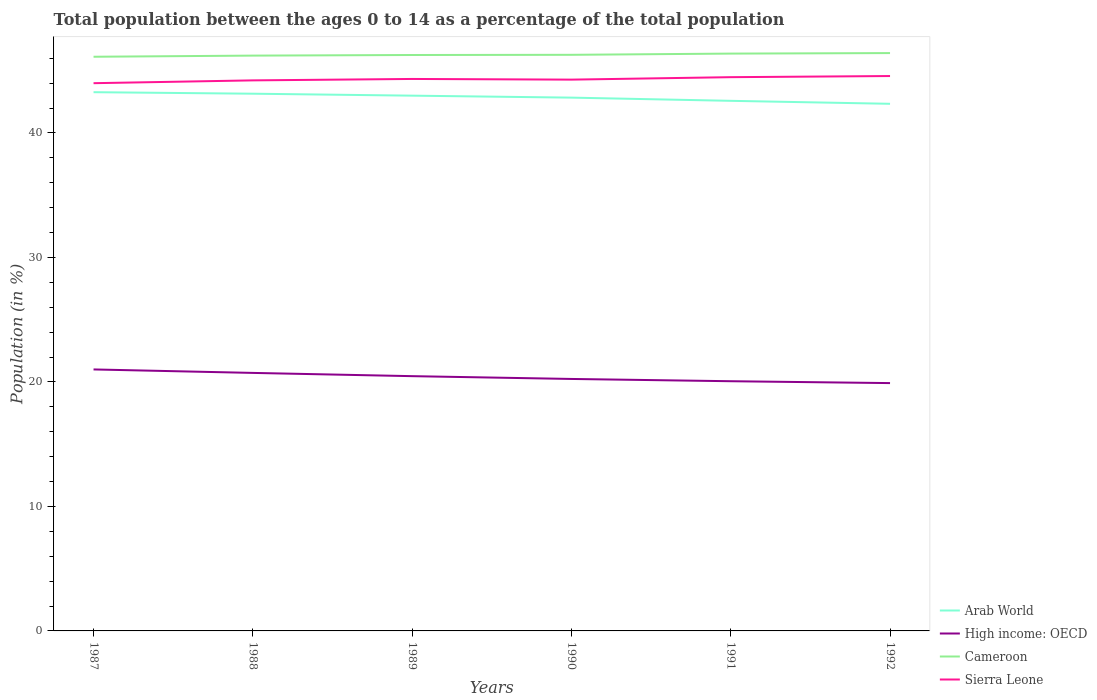Does the line corresponding to Arab World intersect with the line corresponding to Cameroon?
Offer a terse response. No. Across all years, what is the maximum percentage of the population ages 0 to 14 in Sierra Leone?
Offer a very short reply. 44. What is the total percentage of the population ages 0 to 14 in Cameroon in the graph?
Give a very brief answer. -0.05. What is the difference between the highest and the second highest percentage of the population ages 0 to 14 in Arab World?
Ensure brevity in your answer.  0.93. What is the difference between the highest and the lowest percentage of the population ages 0 to 14 in Cameroon?
Offer a terse response. 3. Is the percentage of the population ages 0 to 14 in Cameroon strictly greater than the percentage of the population ages 0 to 14 in High income: OECD over the years?
Offer a terse response. No. How many lines are there?
Give a very brief answer. 4. How many years are there in the graph?
Give a very brief answer. 6. What is the difference between two consecutive major ticks on the Y-axis?
Make the answer very short. 10. Where does the legend appear in the graph?
Your response must be concise. Bottom right. How are the legend labels stacked?
Your response must be concise. Vertical. What is the title of the graph?
Provide a short and direct response. Total population between the ages 0 to 14 as a percentage of the total population. What is the label or title of the Y-axis?
Give a very brief answer. Population (in %). What is the Population (in %) in Arab World in 1987?
Your response must be concise. 43.28. What is the Population (in %) of High income: OECD in 1987?
Provide a succinct answer. 21.01. What is the Population (in %) of Cameroon in 1987?
Offer a very short reply. 46.12. What is the Population (in %) of Sierra Leone in 1987?
Provide a succinct answer. 44. What is the Population (in %) of Arab World in 1988?
Your answer should be compact. 43.16. What is the Population (in %) of High income: OECD in 1988?
Keep it short and to the point. 20.73. What is the Population (in %) of Cameroon in 1988?
Provide a short and direct response. 46.22. What is the Population (in %) in Sierra Leone in 1988?
Your response must be concise. 44.23. What is the Population (in %) in Arab World in 1989?
Make the answer very short. 43. What is the Population (in %) in High income: OECD in 1989?
Give a very brief answer. 20.47. What is the Population (in %) in Cameroon in 1989?
Make the answer very short. 46.26. What is the Population (in %) in Sierra Leone in 1989?
Provide a succinct answer. 44.34. What is the Population (in %) of Arab World in 1990?
Make the answer very short. 42.84. What is the Population (in %) in High income: OECD in 1990?
Offer a very short reply. 20.24. What is the Population (in %) of Cameroon in 1990?
Offer a very short reply. 46.28. What is the Population (in %) of Sierra Leone in 1990?
Your answer should be very brief. 44.29. What is the Population (in %) of Arab World in 1991?
Give a very brief answer. 42.58. What is the Population (in %) in High income: OECD in 1991?
Make the answer very short. 20.06. What is the Population (in %) of Cameroon in 1991?
Provide a short and direct response. 46.38. What is the Population (in %) in Sierra Leone in 1991?
Offer a very short reply. 44.48. What is the Population (in %) of Arab World in 1992?
Keep it short and to the point. 42.35. What is the Population (in %) of High income: OECD in 1992?
Your answer should be very brief. 19.91. What is the Population (in %) of Cameroon in 1992?
Ensure brevity in your answer.  46.42. What is the Population (in %) in Sierra Leone in 1992?
Ensure brevity in your answer.  44.58. Across all years, what is the maximum Population (in %) in Arab World?
Keep it short and to the point. 43.28. Across all years, what is the maximum Population (in %) of High income: OECD?
Ensure brevity in your answer.  21.01. Across all years, what is the maximum Population (in %) in Cameroon?
Make the answer very short. 46.42. Across all years, what is the maximum Population (in %) of Sierra Leone?
Provide a short and direct response. 44.58. Across all years, what is the minimum Population (in %) in Arab World?
Your response must be concise. 42.35. Across all years, what is the minimum Population (in %) in High income: OECD?
Provide a succinct answer. 19.91. Across all years, what is the minimum Population (in %) in Cameroon?
Provide a succinct answer. 46.12. Across all years, what is the minimum Population (in %) in Sierra Leone?
Your answer should be compact. 44. What is the total Population (in %) of Arab World in the graph?
Keep it short and to the point. 257.2. What is the total Population (in %) of High income: OECD in the graph?
Your response must be concise. 122.41. What is the total Population (in %) of Cameroon in the graph?
Provide a short and direct response. 277.68. What is the total Population (in %) in Sierra Leone in the graph?
Provide a succinct answer. 265.91. What is the difference between the Population (in %) in Arab World in 1987 and that in 1988?
Your answer should be very brief. 0.12. What is the difference between the Population (in %) of High income: OECD in 1987 and that in 1988?
Provide a succinct answer. 0.28. What is the difference between the Population (in %) of Cameroon in 1987 and that in 1988?
Your response must be concise. -0.09. What is the difference between the Population (in %) of Sierra Leone in 1987 and that in 1988?
Give a very brief answer. -0.23. What is the difference between the Population (in %) of Arab World in 1987 and that in 1989?
Offer a terse response. 0.28. What is the difference between the Population (in %) in High income: OECD in 1987 and that in 1989?
Your response must be concise. 0.54. What is the difference between the Population (in %) in Cameroon in 1987 and that in 1989?
Offer a terse response. -0.14. What is the difference between the Population (in %) of Sierra Leone in 1987 and that in 1989?
Give a very brief answer. -0.34. What is the difference between the Population (in %) of Arab World in 1987 and that in 1990?
Give a very brief answer. 0.44. What is the difference between the Population (in %) of High income: OECD in 1987 and that in 1990?
Provide a succinct answer. 0.76. What is the difference between the Population (in %) of Cameroon in 1987 and that in 1990?
Your answer should be very brief. -0.16. What is the difference between the Population (in %) in Sierra Leone in 1987 and that in 1990?
Ensure brevity in your answer.  -0.29. What is the difference between the Population (in %) of Arab World in 1987 and that in 1991?
Provide a succinct answer. 0.69. What is the difference between the Population (in %) in High income: OECD in 1987 and that in 1991?
Make the answer very short. 0.95. What is the difference between the Population (in %) in Cameroon in 1987 and that in 1991?
Your answer should be compact. -0.25. What is the difference between the Population (in %) in Sierra Leone in 1987 and that in 1991?
Your answer should be very brief. -0.48. What is the difference between the Population (in %) of Arab World in 1987 and that in 1992?
Give a very brief answer. 0.93. What is the difference between the Population (in %) in High income: OECD in 1987 and that in 1992?
Offer a terse response. 1.1. What is the difference between the Population (in %) in Cameroon in 1987 and that in 1992?
Offer a terse response. -0.3. What is the difference between the Population (in %) in Sierra Leone in 1987 and that in 1992?
Your answer should be compact. -0.58. What is the difference between the Population (in %) in Arab World in 1988 and that in 1989?
Your answer should be compact. 0.16. What is the difference between the Population (in %) in High income: OECD in 1988 and that in 1989?
Make the answer very short. 0.26. What is the difference between the Population (in %) of Cameroon in 1988 and that in 1989?
Keep it short and to the point. -0.05. What is the difference between the Population (in %) in Sierra Leone in 1988 and that in 1989?
Your answer should be compact. -0.11. What is the difference between the Population (in %) of Arab World in 1988 and that in 1990?
Provide a short and direct response. 0.32. What is the difference between the Population (in %) in High income: OECD in 1988 and that in 1990?
Give a very brief answer. 0.48. What is the difference between the Population (in %) of Cameroon in 1988 and that in 1990?
Keep it short and to the point. -0.06. What is the difference between the Population (in %) in Sierra Leone in 1988 and that in 1990?
Offer a terse response. -0.06. What is the difference between the Population (in %) in Arab World in 1988 and that in 1991?
Keep it short and to the point. 0.57. What is the difference between the Population (in %) of High income: OECD in 1988 and that in 1991?
Provide a short and direct response. 0.67. What is the difference between the Population (in %) in Cameroon in 1988 and that in 1991?
Keep it short and to the point. -0.16. What is the difference between the Population (in %) in Sierra Leone in 1988 and that in 1991?
Ensure brevity in your answer.  -0.26. What is the difference between the Population (in %) of Arab World in 1988 and that in 1992?
Offer a very short reply. 0.81. What is the difference between the Population (in %) of High income: OECD in 1988 and that in 1992?
Keep it short and to the point. 0.82. What is the difference between the Population (in %) in Cameroon in 1988 and that in 1992?
Offer a terse response. -0.2. What is the difference between the Population (in %) of Sierra Leone in 1988 and that in 1992?
Offer a very short reply. -0.35. What is the difference between the Population (in %) of Arab World in 1989 and that in 1990?
Keep it short and to the point. 0.16. What is the difference between the Population (in %) in High income: OECD in 1989 and that in 1990?
Ensure brevity in your answer.  0.22. What is the difference between the Population (in %) in Cameroon in 1989 and that in 1990?
Keep it short and to the point. -0.02. What is the difference between the Population (in %) of Sierra Leone in 1989 and that in 1990?
Your answer should be compact. 0.05. What is the difference between the Population (in %) in Arab World in 1989 and that in 1991?
Your answer should be very brief. 0.42. What is the difference between the Population (in %) of High income: OECD in 1989 and that in 1991?
Ensure brevity in your answer.  0.41. What is the difference between the Population (in %) of Cameroon in 1989 and that in 1991?
Your response must be concise. -0.11. What is the difference between the Population (in %) in Sierra Leone in 1989 and that in 1991?
Make the answer very short. -0.14. What is the difference between the Population (in %) in Arab World in 1989 and that in 1992?
Keep it short and to the point. 0.65. What is the difference between the Population (in %) in High income: OECD in 1989 and that in 1992?
Provide a short and direct response. 0.56. What is the difference between the Population (in %) of Cameroon in 1989 and that in 1992?
Your answer should be very brief. -0.15. What is the difference between the Population (in %) of Sierra Leone in 1989 and that in 1992?
Give a very brief answer. -0.24. What is the difference between the Population (in %) in Arab World in 1990 and that in 1991?
Your response must be concise. 0.26. What is the difference between the Population (in %) of High income: OECD in 1990 and that in 1991?
Provide a short and direct response. 0.18. What is the difference between the Population (in %) of Cameroon in 1990 and that in 1991?
Give a very brief answer. -0.1. What is the difference between the Population (in %) in Sierra Leone in 1990 and that in 1991?
Provide a short and direct response. -0.2. What is the difference between the Population (in %) of Arab World in 1990 and that in 1992?
Provide a short and direct response. 0.5. What is the difference between the Population (in %) of High income: OECD in 1990 and that in 1992?
Keep it short and to the point. 0.33. What is the difference between the Population (in %) of Cameroon in 1990 and that in 1992?
Provide a succinct answer. -0.14. What is the difference between the Population (in %) in Sierra Leone in 1990 and that in 1992?
Provide a succinct answer. -0.29. What is the difference between the Population (in %) of Arab World in 1991 and that in 1992?
Offer a very short reply. 0.24. What is the difference between the Population (in %) in High income: OECD in 1991 and that in 1992?
Your answer should be very brief. 0.15. What is the difference between the Population (in %) of Cameroon in 1991 and that in 1992?
Provide a succinct answer. -0.04. What is the difference between the Population (in %) in Sierra Leone in 1991 and that in 1992?
Keep it short and to the point. -0.09. What is the difference between the Population (in %) of Arab World in 1987 and the Population (in %) of High income: OECD in 1988?
Your answer should be very brief. 22.55. What is the difference between the Population (in %) of Arab World in 1987 and the Population (in %) of Cameroon in 1988?
Your response must be concise. -2.94. What is the difference between the Population (in %) in Arab World in 1987 and the Population (in %) in Sierra Leone in 1988?
Give a very brief answer. -0.95. What is the difference between the Population (in %) of High income: OECD in 1987 and the Population (in %) of Cameroon in 1988?
Ensure brevity in your answer.  -25.21. What is the difference between the Population (in %) in High income: OECD in 1987 and the Population (in %) in Sierra Leone in 1988?
Your answer should be very brief. -23.22. What is the difference between the Population (in %) of Cameroon in 1987 and the Population (in %) of Sierra Leone in 1988?
Your answer should be compact. 1.9. What is the difference between the Population (in %) of Arab World in 1987 and the Population (in %) of High income: OECD in 1989?
Provide a succinct answer. 22.81. What is the difference between the Population (in %) of Arab World in 1987 and the Population (in %) of Cameroon in 1989?
Offer a very short reply. -2.99. What is the difference between the Population (in %) in Arab World in 1987 and the Population (in %) in Sierra Leone in 1989?
Give a very brief answer. -1.06. What is the difference between the Population (in %) of High income: OECD in 1987 and the Population (in %) of Cameroon in 1989?
Your answer should be very brief. -25.26. What is the difference between the Population (in %) of High income: OECD in 1987 and the Population (in %) of Sierra Leone in 1989?
Your answer should be compact. -23.34. What is the difference between the Population (in %) in Cameroon in 1987 and the Population (in %) in Sierra Leone in 1989?
Your response must be concise. 1.78. What is the difference between the Population (in %) of Arab World in 1987 and the Population (in %) of High income: OECD in 1990?
Offer a very short reply. 23.04. What is the difference between the Population (in %) of Arab World in 1987 and the Population (in %) of Cameroon in 1990?
Your response must be concise. -3. What is the difference between the Population (in %) of Arab World in 1987 and the Population (in %) of Sierra Leone in 1990?
Offer a very short reply. -1.01. What is the difference between the Population (in %) in High income: OECD in 1987 and the Population (in %) in Cameroon in 1990?
Make the answer very short. -25.27. What is the difference between the Population (in %) of High income: OECD in 1987 and the Population (in %) of Sierra Leone in 1990?
Offer a terse response. -23.28. What is the difference between the Population (in %) in Cameroon in 1987 and the Population (in %) in Sierra Leone in 1990?
Give a very brief answer. 1.84. What is the difference between the Population (in %) in Arab World in 1987 and the Population (in %) in High income: OECD in 1991?
Keep it short and to the point. 23.22. What is the difference between the Population (in %) in Arab World in 1987 and the Population (in %) in Cameroon in 1991?
Provide a succinct answer. -3.1. What is the difference between the Population (in %) in Arab World in 1987 and the Population (in %) in Sierra Leone in 1991?
Your answer should be compact. -1.21. What is the difference between the Population (in %) in High income: OECD in 1987 and the Population (in %) in Cameroon in 1991?
Your answer should be very brief. -25.37. What is the difference between the Population (in %) in High income: OECD in 1987 and the Population (in %) in Sierra Leone in 1991?
Your answer should be compact. -23.48. What is the difference between the Population (in %) in Cameroon in 1987 and the Population (in %) in Sierra Leone in 1991?
Provide a succinct answer. 1.64. What is the difference between the Population (in %) in Arab World in 1987 and the Population (in %) in High income: OECD in 1992?
Make the answer very short. 23.37. What is the difference between the Population (in %) in Arab World in 1987 and the Population (in %) in Cameroon in 1992?
Give a very brief answer. -3.14. What is the difference between the Population (in %) of Arab World in 1987 and the Population (in %) of Sierra Leone in 1992?
Offer a terse response. -1.3. What is the difference between the Population (in %) of High income: OECD in 1987 and the Population (in %) of Cameroon in 1992?
Provide a short and direct response. -25.41. What is the difference between the Population (in %) in High income: OECD in 1987 and the Population (in %) in Sierra Leone in 1992?
Your answer should be compact. -23.57. What is the difference between the Population (in %) in Cameroon in 1987 and the Population (in %) in Sierra Leone in 1992?
Your answer should be compact. 1.55. What is the difference between the Population (in %) in Arab World in 1988 and the Population (in %) in High income: OECD in 1989?
Make the answer very short. 22.69. What is the difference between the Population (in %) of Arab World in 1988 and the Population (in %) of Cameroon in 1989?
Keep it short and to the point. -3.11. What is the difference between the Population (in %) in Arab World in 1988 and the Population (in %) in Sierra Leone in 1989?
Keep it short and to the point. -1.18. What is the difference between the Population (in %) in High income: OECD in 1988 and the Population (in %) in Cameroon in 1989?
Offer a terse response. -25.54. What is the difference between the Population (in %) in High income: OECD in 1988 and the Population (in %) in Sierra Leone in 1989?
Make the answer very short. -23.61. What is the difference between the Population (in %) of Cameroon in 1988 and the Population (in %) of Sierra Leone in 1989?
Ensure brevity in your answer.  1.88. What is the difference between the Population (in %) of Arab World in 1988 and the Population (in %) of High income: OECD in 1990?
Keep it short and to the point. 22.91. What is the difference between the Population (in %) in Arab World in 1988 and the Population (in %) in Cameroon in 1990?
Ensure brevity in your answer.  -3.12. What is the difference between the Population (in %) in Arab World in 1988 and the Population (in %) in Sierra Leone in 1990?
Offer a terse response. -1.13. What is the difference between the Population (in %) of High income: OECD in 1988 and the Population (in %) of Cameroon in 1990?
Provide a succinct answer. -25.55. What is the difference between the Population (in %) of High income: OECD in 1988 and the Population (in %) of Sierra Leone in 1990?
Provide a short and direct response. -23.56. What is the difference between the Population (in %) of Cameroon in 1988 and the Population (in %) of Sierra Leone in 1990?
Your answer should be compact. 1.93. What is the difference between the Population (in %) of Arab World in 1988 and the Population (in %) of High income: OECD in 1991?
Provide a succinct answer. 23.1. What is the difference between the Population (in %) in Arab World in 1988 and the Population (in %) in Cameroon in 1991?
Ensure brevity in your answer.  -3.22. What is the difference between the Population (in %) of Arab World in 1988 and the Population (in %) of Sierra Leone in 1991?
Offer a very short reply. -1.33. What is the difference between the Population (in %) of High income: OECD in 1988 and the Population (in %) of Cameroon in 1991?
Your response must be concise. -25.65. What is the difference between the Population (in %) of High income: OECD in 1988 and the Population (in %) of Sierra Leone in 1991?
Give a very brief answer. -23.76. What is the difference between the Population (in %) in Cameroon in 1988 and the Population (in %) in Sierra Leone in 1991?
Offer a terse response. 1.73. What is the difference between the Population (in %) in Arab World in 1988 and the Population (in %) in High income: OECD in 1992?
Offer a very short reply. 23.25. What is the difference between the Population (in %) of Arab World in 1988 and the Population (in %) of Cameroon in 1992?
Provide a succinct answer. -3.26. What is the difference between the Population (in %) of Arab World in 1988 and the Population (in %) of Sierra Leone in 1992?
Provide a short and direct response. -1.42. What is the difference between the Population (in %) in High income: OECD in 1988 and the Population (in %) in Cameroon in 1992?
Provide a short and direct response. -25.69. What is the difference between the Population (in %) in High income: OECD in 1988 and the Population (in %) in Sierra Leone in 1992?
Offer a terse response. -23.85. What is the difference between the Population (in %) in Cameroon in 1988 and the Population (in %) in Sierra Leone in 1992?
Give a very brief answer. 1.64. What is the difference between the Population (in %) of Arab World in 1989 and the Population (in %) of High income: OECD in 1990?
Your response must be concise. 22.76. What is the difference between the Population (in %) of Arab World in 1989 and the Population (in %) of Cameroon in 1990?
Give a very brief answer. -3.28. What is the difference between the Population (in %) in Arab World in 1989 and the Population (in %) in Sierra Leone in 1990?
Offer a terse response. -1.29. What is the difference between the Population (in %) of High income: OECD in 1989 and the Population (in %) of Cameroon in 1990?
Your answer should be very brief. -25.81. What is the difference between the Population (in %) in High income: OECD in 1989 and the Population (in %) in Sierra Leone in 1990?
Give a very brief answer. -23.82. What is the difference between the Population (in %) of Cameroon in 1989 and the Population (in %) of Sierra Leone in 1990?
Your response must be concise. 1.98. What is the difference between the Population (in %) of Arab World in 1989 and the Population (in %) of High income: OECD in 1991?
Give a very brief answer. 22.94. What is the difference between the Population (in %) in Arab World in 1989 and the Population (in %) in Cameroon in 1991?
Your answer should be compact. -3.38. What is the difference between the Population (in %) in Arab World in 1989 and the Population (in %) in Sierra Leone in 1991?
Ensure brevity in your answer.  -1.48. What is the difference between the Population (in %) in High income: OECD in 1989 and the Population (in %) in Cameroon in 1991?
Make the answer very short. -25.91. What is the difference between the Population (in %) of High income: OECD in 1989 and the Population (in %) of Sierra Leone in 1991?
Offer a very short reply. -24.02. What is the difference between the Population (in %) of Cameroon in 1989 and the Population (in %) of Sierra Leone in 1991?
Offer a very short reply. 1.78. What is the difference between the Population (in %) in Arab World in 1989 and the Population (in %) in High income: OECD in 1992?
Provide a succinct answer. 23.09. What is the difference between the Population (in %) of Arab World in 1989 and the Population (in %) of Cameroon in 1992?
Offer a very short reply. -3.42. What is the difference between the Population (in %) of Arab World in 1989 and the Population (in %) of Sierra Leone in 1992?
Provide a succinct answer. -1.58. What is the difference between the Population (in %) in High income: OECD in 1989 and the Population (in %) in Cameroon in 1992?
Provide a succinct answer. -25.95. What is the difference between the Population (in %) of High income: OECD in 1989 and the Population (in %) of Sierra Leone in 1992?
Provide a succinct answer. -24.11. What is the difference between the Population (in %) in Cameroon in 1989 and the Population (in %) in Sierra Leone in 1992?
Provide a short and direct response. 1.69. What is the difference between the Population (in %) of Arab World in 1990 and the Population (in %) of High income: OECD in 1991?
Your response must be concise. 22.78. What is the difference between the Population (in %) in Arab World in 1990 and the Population (in %) in Cameroon in 1991?
Your answer should be compact. -3.54. What is the difference between the Population (in %) of Arab World in 1990 and the Population (in %) of Sierra Leone in 1991?
Keep it short and to the point. -1.64. What is the difference between the Population (in %) in High income: OECD in 1990 and the Population (in %) in Cameroon in 1991?
Make the answer very short. -26.14. What is the difference between the Population (in %) in High income: OECD in 1990 and the Population (in %) in Sierra Leone in 1991?
Ensure brevity in your answer.  -24.24. What is the difference between the Population (in %) of Cameroon in 1990 and the Population (in %) of Sierra Leone in 1991?
Your response must be concise. 1.8. What is the difference between the Population (in %) of Arab World in 1990 and the Population (in %) of High income: OECD in 1992?
Your answer should be compact. 22.93. What is the difference between the Population (in %) of Arab World in 1990 and the Population (in %) of Cameroon in 1992?
Offer a very short reply. -3.58. What is the difference between the Population (in %) in Arab World in 1990 and the Population (in %) in Sierra Leone in 1992?
Provide a succinct answer. -1.74. What is the difference between the Population (in %) in High income: OECD in 1990 and the Population (in %) in Cameroon in 1992?
Your answer should be compact. -26.18. What is the difference between the Population (in %) in High income: OECD in 1990 and the Population (in %) in Sierra Leone in 1992?
Your response must be concise. -24.33. What is the difference between the Population (in %) of Cameroon in 1990 and the Population (in %) of Sierra Leone in 1992?
Provide a succinct answer. 1.7. What is the difference between the Population (in %) of Arab World in 1991 and the Population (in %) of High income: OECD in 1992?
Your answer should be compact. 22.68. What is the difference between the Population (in %) in Arab World in 1991 and the Population (in %) in Cameroon in 1992?
Your answer should be very brief. -3.84. What is the difference between the Population (in %) in Arab World in 1991 and the Population (in %) in Sierra Leone in 1992?
Your response must be concise. -1.99. What is the difference between the Population (in %) in High income: OECD in 1991 and the Population (in %) in Cameroon in 1992?
Provide a succinct answer. -26.36. What is the difference between the Population (in %) in High income: OECD in 1991 and the Population (in %) in Sierra Leone in 1992?
Provide a short and direct response. -24.52. What is the difference between the Population (in %) of Cameroon in 1991 and the Population (in %) of Sierra Leone in 1992?
Provide a succinct answer. 1.8. What is the average Population (in %) in Arab World per year?
Make the answer very short. 42.87. What is the average Population (in %) in High income: OECD per year?
Your response must be concise. 20.4. What is the average Population (in %) in Cameroon per year?
Offer a terse response. 46.28. What is the average Population (in %) of Sierra Leone per year?
Make the answer very short. 44.32. In the year 1987, what is the difference between the Population (in %) in Arab World and Population (in %) in High income: OECD?
Keep it short and to the point. 22.27. In the year 1987, what is the difference between the Population (in %) of Arab World and Population (in %) of Cameroon?
Offer a terse response. -2.85. In the year 1987, what is the difference between the Population (in %) in Arab World and Population (in %) in Sierra Leone?
Offer a very short reply. -0.72. In the year 1987, what is the difference between the Population (in %) in High income: OECD and Population (in %) in Cameroon?
Provide a succinct answer. -25.12. In the year 1987, what is the difference between the Population (in %) in High income: OECD and Population (in %) in Sierra Leone?
Ensure brevity in your answer.  -22.99. In the year 1987, what is the difference between the Population (in %) of Cameroon and Population (in %) of Sierra Leone?
Give a very brief answer. 2.12. In the year 1988, what is the difference between the Population (in %) in Arab World and Population (in %) in High income: OECD?
Ensure brevity in your answer.  22.43. In the year 1988, what is the difference between the Population (in %) of Arab World and Population (in %) of Cameroon?
Your answer should be compact. -3.06. In the year 1988, what is the difference between the Population (in %) in Arab World and Population (in %) in Sierra Leone?
Keep it short and to the point. -1.07. In the year 1988, what is the difference between the Population (in %) in High income: OECD and Population (in %) in Cameroon?
Your answer should be compact. -25.49. In the year 1988, what is the difference between the Population (in %) in High income: OECD and Population (in %) in Sierra Leone?
Make the answer very short. -23.5. In the year 1988, what is the difference between the Population (in %) of Cameroon and Population (in %) of Sierra Leone?
Your response must be concise. 1.99. In the year 1989, what is the difference between the Population (in %) in Arab World and Population (in %) in High income: OECD?
Provide a succinct answer. 22.53. In the year 1989, what is the difference between the Population (in %) of Arab World and Population (in %) of Cameroon?
Make the answer very short. -3.27. In the year 1989, what is the difference between the Population (in %) of Arab World and Population (in %) of Sierra Leone?
Ensure brevity in your answer.  -1.34. In the year 1989, what is the difference between the Population (in %) of High income: OECD and Population (in %) of Cameroon?
Ensure brevity in your answer.  -25.8. In the year 1989, what is the difference between the Population (in %) in High income: OECD and Population (in %) in Sierra Leone?
Ensure brevity in your answer.  -23.87. In the year 1989, what is the difference between the Population (in %) of Cameroon and Population (in %) of Sierra Leone?
Provide a succinct answer. 1.92. In the year 1990, what is the difference between the Population (in %) in Arab World and Population (in %) in High income: OECD?
Offer a very short reply. 22.6. In the year 1990, what is the difference between the Population (in %) of Arab World and Population (in %) of Cameroon?
Offer a terse response. -3.44. In the year 1990, what is the difference between the Population (in %) in Arab World and Population (in %) in Sierra Leone?
Keep it short and to the point. -1.45. In the year 1990, what is the difference between the Population (in %) of High income: OECD and Population (in %) of Cameroon?
Ensure brevity in your answer.  -26.04. In the year 1990, what is the difference between the Population (in %) of High income: OECD and Population (in %) of Sierra Leone?
Your answer should be very brief. -24.05. In the year 1990, what is the difference between the Population (in %) of Cameroon and Population (in %) of Sierra Leone?
Make the answer very short. 1.99. In the year 1991, what is the difference between the Population (in %) of Arab World and Population (in %) of High income: OECD?
Your answer should be compact. 22.52. In the year 1991, what is the difference between the Population (in %) of Arab World and Population (in %) of Cameroon?
Your answer should be very brief. -3.79. In the year 1991, what is the difference between the Population (in %) in Arab World and Population (in %) in Sierra Leone?
Ensure brevity in your answer.  -1.9. In the year 1991, what is the difference between the Population (in %) of High income: OECD and Population (in %) of Cameroon?
Offer a terse response. -26.32. In the year 1991, what is the difference between the Population (in %) in High income: OECD and Population (in %) in Sierra Leone?
Your response must be concise. -24.42. In the year 1991, what is the difference between the Population (in %) in Cameroon and Population (in %) in Sierra Leone?
Provide a succinct answer. 1.89. In the year 1992, what is the difference between the Population (in %) in Arab World and Population (in %) in High income: OECD?
Your answer should be very brief. 22.44. In the year 1992, what is the difference between the Population (in %) in Arab World and Population (in %) in Cameroon?
Your response must be concise. -4.07. In the year 1992, what is the difference between the Population (in %) in Arab World and Population (in %) in Sierra Leone?
Your answer should be compact. -2.23. In the year 1992, what is the difference between the Population (in %) in High income: OECD and Population (in %) in Cameroon?
Ensure brevity in your answer.  -26.51. In the year 1992, what is the difference between the Population (in %) of High income: OECD and Population (in %) of Sierra Leone?
Your answer should be very brief. -24.67. In the year 1992, what is the difference between the Population (in %) of Cameroon and Population (in %) of Sierra Leone?
Your answer should be very brief. 1.84. What is the ratio of the Population (in %) in High income: OECD in 1987 to that in 1988?
Your answer should be very brief. 1.01. What is the ratio of the Population (in %) of Cameroon in 1987 to that in 1988?
Provide a succinct answer. 1. What is the ratio of the Population (in %) in Sierra Leone in 1987 to that in 1988?
Your response must be concise. 0.99. What is the ratio of the Population (in %) in Arab World in 1987 to that in 1989?
Make the answer very short. 1.01. What is the ratio of the Population (in %) in High income: OECD in 1987 to that in 1989?
Offer a terse response. 1.03. What is the ratio of the Population (in %) of Cameroon in 1987 to that in 1989?
Offer a very short reply. 1. What is the ratio of the Population (in %) in Sierra Leone in 1987 to that in 1989?
Ensure brevity in your answer.  0.99. What is the ratio of the Population (in %) of Arab World in 1987 to that in 1990?
Provide a short and direct response. 1.01. What is the ratio of the Population (in %) in High income: OECD in 1987 to that in 1990?
Make the answer very short. 1.04. What is the ratio of the Population (in %) of Cameroon in 1987 to that in 1990?
Offer a very short reply. 1. What is the ratio of the Population (in %) in Arab World in 1987 to that in 1991?
Make the answer very short. 1.02. What is the ratio of the Population (in %) of High income: OECD in 1987 to that in 1991?
Your answer should be compact. 1.05. What is the ratio of the Population (in %) in Sierra Leone in 1987 to that in 1991?
Provide a succinct answer. 0.99. What is the ratio of the Population (in %) of High income: OECD in 1987 to that in 1992?
Your response must be concise. 1.06. What is the ratio of the Population (in %) of Sierra Leone in 1987 to that in 1992?
Offer a terse response. 0.99. What is the ratio of the Population (in %) in High income: OECD in 1988 to that in 1989?
Your response must be concise. 1.01. What is the ratio of the Population (in %) of Arab World in 1988 to that in 1990?
Your answer should be very brief. 1.01. What is the ratio of the Population (in %) in High income: OECD in 1988 to that in 1990?
Offer a terse response. 1.02. What is the ratio of the Population (in %) of Cameroon in 1988 to that in 1990?
Provide a succinct answer. 1. What is the ratio of the Population (in %) in Arab World in 1988 to that in 1991?
Offer a very short reply. 1.01. What is the ratio of the Population (in %) in Cameroon in 1988 to that in 1991?
Give a very brief answer. 1. What is the ratio of the Population (in %) in Arab World in 1988 to that in 1992?
Your answer should be very brief. 1.02. What is the ratio of the Population (in %) in High income: OECD in 1988 to that in 1992?
Make the answer very short. 1.04. What is the ratio of the Population (in %) in Sierra Leone in 1988 to that in 1992?
Make the answer very short. 0.99. What is the ratio of the Population (in %) of Arab World in 1989 to that in 1990?
Your response must be concise. 1. What is the ratio of the Population (in %) in High income: OECD in 1989 to that in 1990?
Offer a very short reply. 1.01. What is the ratio of the Population (in %) in Arab World in 1989 to that in 1991?
Provide a short and direct response. 1.01. What is the ratio of the Population (in %) in High income: OECD in 1989 to that in 1991?
Keep it short and to the point. 1.02. What is the ratio of the Population (in %) in Cameroon in 1989 to that in 1991?
Provide a succinct answer. 1. What is the ratio of the Population (in %) of Arab World in 1989 to that in 1992?
Offer a terse response. 1.02. What is the ratio of the Population (in %) in High income: OECD in 1989 to that in 1992?
Offer a very short reply. 1.03. What is the ratio of the Population (in %) in Sierra Leone in 1989 to that in 1992?
Your response must be concise. 0.99. What is the ratio of the Population (in %) in Arab World in 1990 to that in 1991?
Provide a short and direct response. 1.01. What is the ratio of the Population (in %) of High income: OECD in 1990 to that in 1991?
Your answer should be very brief. 1.01. What is the ratio of the Population (in %) of Arab World in 1990 to that in 1992?
Your answer should be compact. 1.01. What is the ratio of the Population (in %) in High income: OECD in 1990 to that in 1992?
Give a very brief answer. 1.02. What is the ratio of the Population (in %) in Cameroon in 1990 to that in 1992?
Your answer should be very brief. 1. What is the ratio of the Population (in %) of Arab World in 1991 to that in 1992?
Offer a terse response. 1.01. What is the ratio of the Population (in %) of High income: OECD in 1991 to that in 1992?
Your answer should be very brief. 1.01. What is the ratio of the Population (in %) in Cameroon in 1991 to that in 1992?
Provide a short and direct response. 1. What is the difference between the highest and the second highest Population (in %) in Arab World?
Provide a short and direct response. 0.12. What is the difference between the highest and the second highest Population (in %) of High income: OECD?
Make the answer very short. 0.28. What is the difference between the highest and the second highest Population (in %) in Cameroon?
Keep it short and to the point. 0.04. What is the difference between the highest and the second highest Population (in %) in Sierra Leone?
Your answer should be compact. 0.09. What is the difference between the highest and the lowest Population (in %) in Arab World?
Provide a succinct answer. 0.93. What is the difference between the highest and the lowest Population (in %) of High income: OECD?
Your answer should be very brief. 1.1. What is the difference between the highest and the lowest Population (in %) in Cameroon?
Ensure brevity in your answer.  0.3. What is the difference between the highest and the lowest Population (in %) in Sierra Leone?
Offer a terse response. 0.58. 